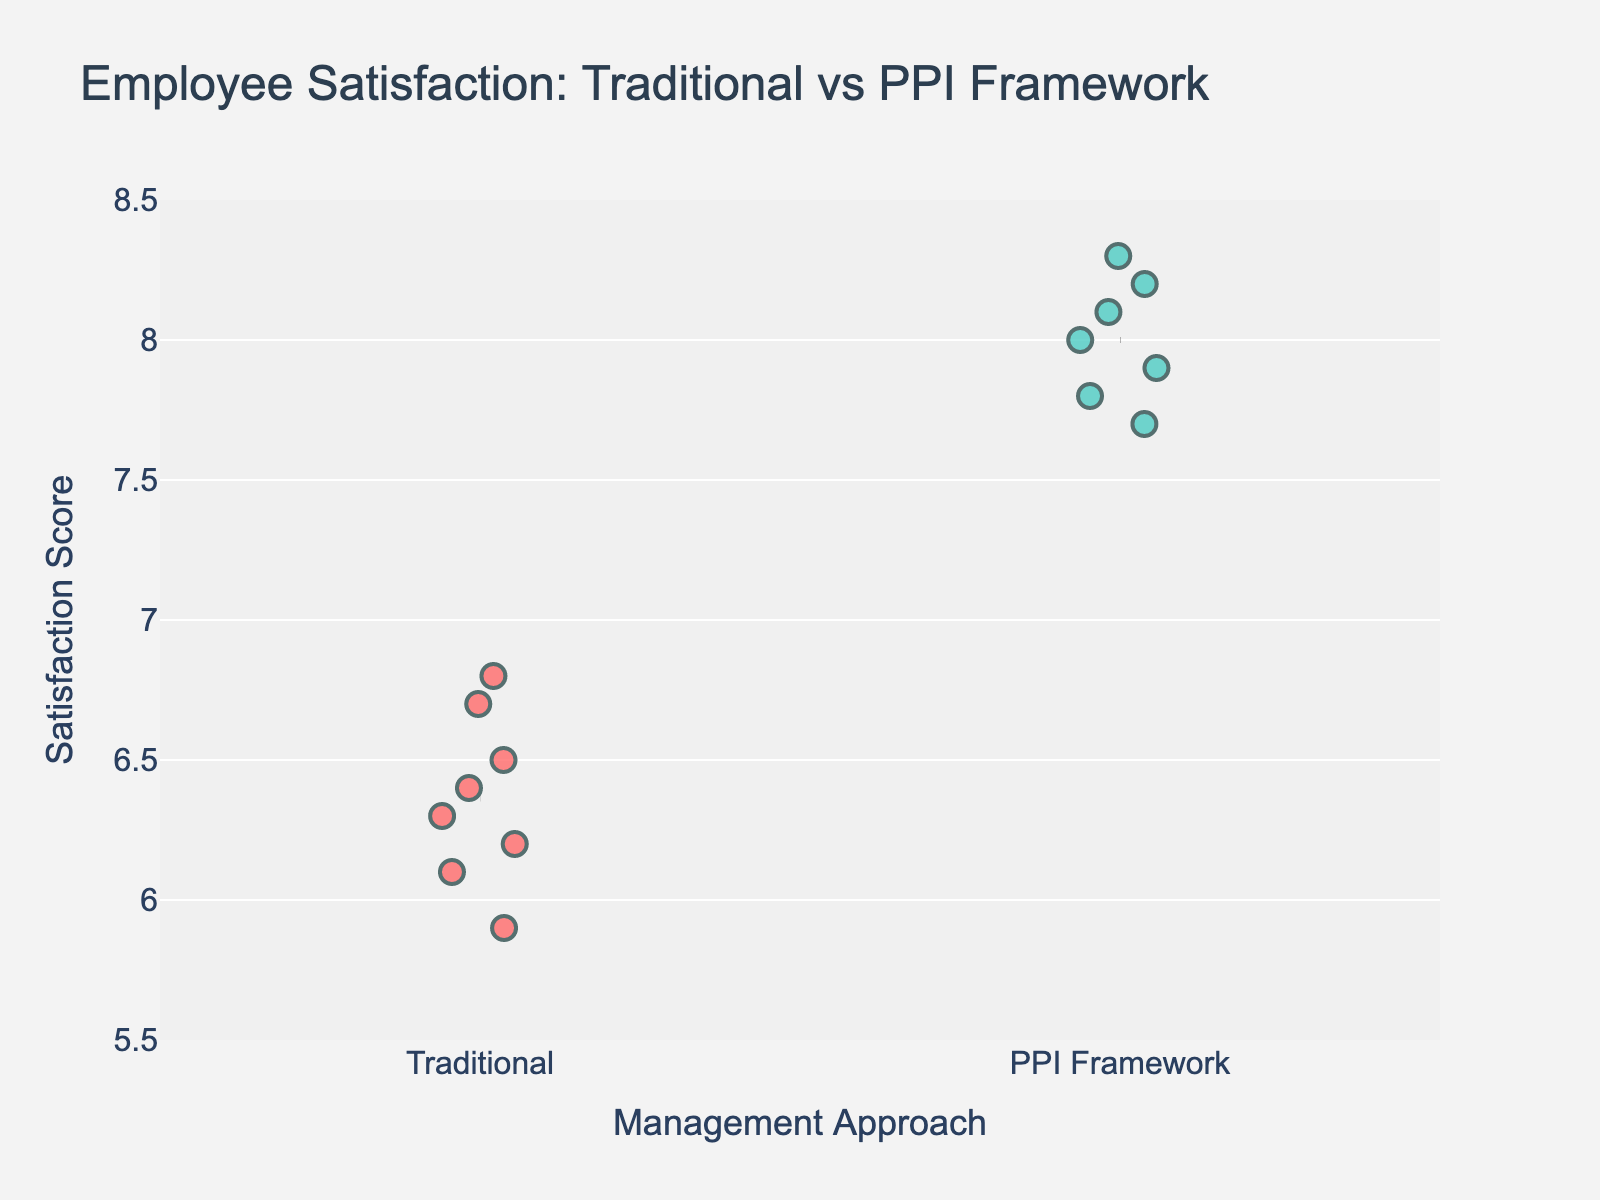What is the title of the plot? The title is located at the top of the plot and provides a summary of what the data represents. In this case, the title reads "Employee Satisfaction: Traditional vs PPI Framework"
Answer: Employee Satisfaction: Traditional vs PPI Framework What colors are used to represent the Traditional and PPI Framework approaches? The color for each approach can be identified by looking at the legend or the data points. Traditional management is represented by red, and the PPI Framework is represented by green.
Answer: Red and green How many data points are there in the PPI Framework group? To find the number of data points in the PPI Framework group, we count the individual points shown on the plot under the "PPI Framework" category.
Answer: 7 What is the range of employee satisfaction scores shown on the y-axis? The y-axis range is indicated by the lowest and highest marks on the axis. In this plot, it ranges from 5.5 to 8.5.
Answer: 5.5 to 8.5 Which company has the highest employee satisfaction score? By examining the data points and their labels, we identify that EY, under the PPI Framework, has the highest satisfaction score of 8.3.
Answer: EY What is the average employee satisfaction score for companies using Traditional management? To find the average, we sum the satisfaction scores of all companies using Traditional management and divide by the number of companies. The scores are 6.2, 6.8, 5.9, 6.5, 6.1, 6.3, 6.7, and 6.4. The sum is 50.9 and there are 8 companies. The average is 50.9 / 8.
Answer: 6.36 Compare the mean satisfaction scores of the two management approaches. Which is higher? The mean satisfaction score for each approach can be found by locating the horizontal line indicating the mean in each group. The mean for the PPI Framework is higher than that for Traditional management.
Answer: PPI Framework is higher What is the difference in employee satisfaction scores between the highest-scoring company using Traditional management and the highest-scoring company using the PPI Framework? The highest score in Traditional management is 6.8 (Microsoft), and the highest in the PPI Framework is 8.3 (EY). The difference is 8.3 - 6.8.
Answer: 1.5 What is the satisfaction score of the company with the lowest score under the PPI Framework? By examining the plot, the lowest score under the PPI Framework is identified as 7.7 (KPMG).
Answer: 7.7 